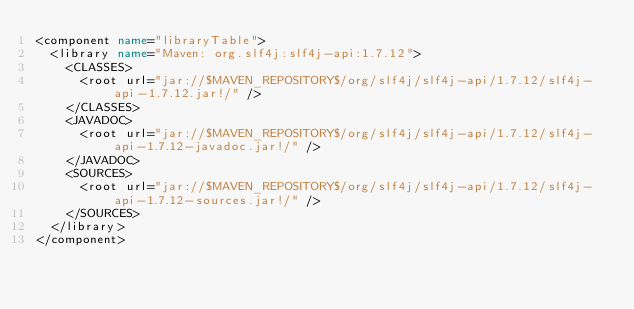Convert code to text. <code><loc_0><loc_0><loc_500><loc_500><_XML_><component name="libraryTable">
  <library name="Maven: org.slf4j:slf4j-api:1.7.12">
    <CLASSES>
      <root url="jar://$MAVEN_REPOSITORY$/org/slf4j/slf4j-api/1.7.12/slf4j-api-1.7.12.jar!/" />
    </CLASSES>
    <JAVADOC>
      <root url="jar://$MAVEN_REPOSITORY$/org/slf4j/slf4j-api/1.7.12/slf4j-api-1.7.12-javadoc.jar!/" />
    </JAVADOC>
    <SOURCES>
      <root url="jar://$MAVEN_REPOSITORY$/org/slf4j/slf4j-api/1.7.12/slf4j-api-1.7.12-sources.jar!/" />
    </SOURCES>
  </library>
</component></code> 